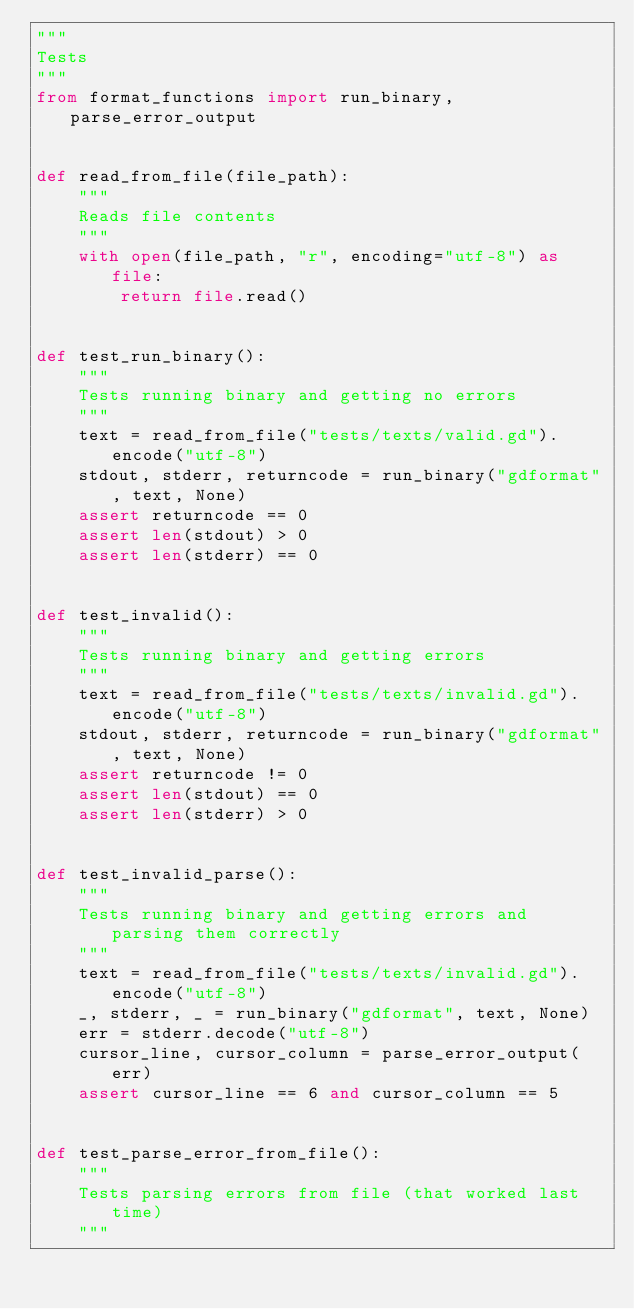Convert code to text. <code><loc_0><loc_0><loc_500><loc_500><_Python_>"""
Tests
"""
from format_functions import run_binary, parse_error_output


def read_from_file(file_path):
    """
    Reads file contents
    """
    with open(file_path, "r", encoding="utf-8") as file:
        return file.read()


def test_run_binary():
    """
    Tests running binary and getting no errors
    """
    text = read_from_file("tests/texts/valid.gd").encode("utf-8")
    stdout, stderr, returncode = run_binary("gdformat", text, None)
    assert returncode == 0
    assert len(stdout) > 0
    assert len(stderr) == 0


def test_invalid():
    """
    Tests running binary and getting errors
    """
    text = read_from_file("tests/texts/invalid.gd").encode("utf-8")
    stdout, stderr, returncode = run_binary("gdformat", text, None)
    assert returncode != 0
    assert len(stdout) == 0
    assert len(stderr) > 0


def test_invalid_parse():
    """
    Tests running binary and getting errors and parsing them correctly
    """
    text = read_from_file("tests/texts/invalid.gd").encode("utf-8")
    _, stderr, _ = run_binary("gdformat", text, None)
    err = stderr.decode("utf-8")
    cursor_line, cursor_column = parse_error_output(err)
    assert cursor_line == 6 and cursor_column == 5


def test_parse_error_from_file():
    """
    Tests parsing errors from file (that worked last time)
    """</code> 